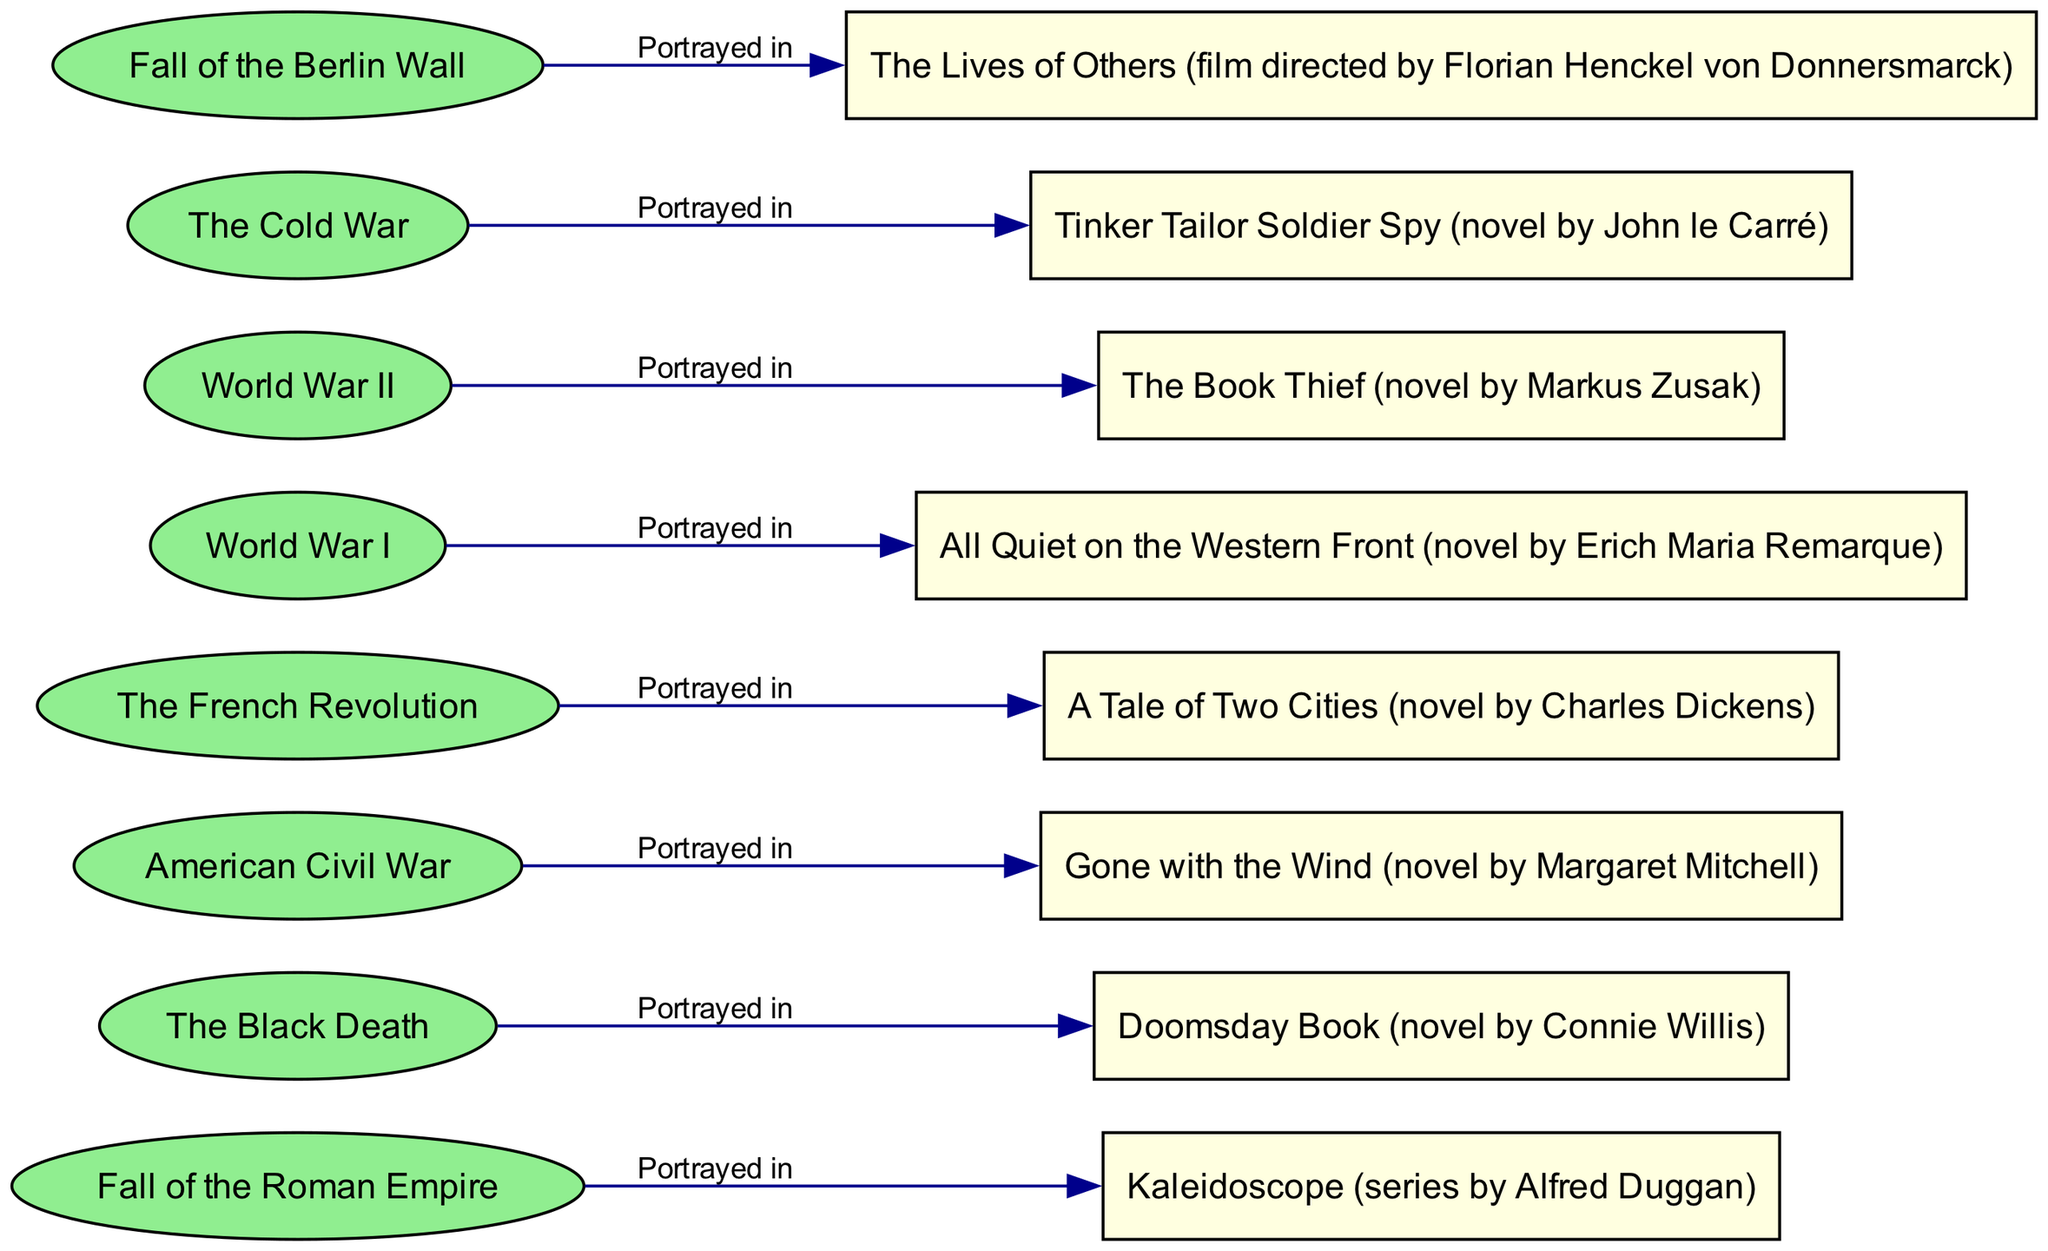What event is portrayed in "Gone with the Wind"? To answer this question, one must locate the fictional portrayal "Gone with the Wind" in the diagram and trace the connecting edge back to the event node. This indicates the event associated with that portrayal. The diagram shows that "Gone with the Wind" is linked to the "American Civil War".
Answer: American Civil War How many fictional portrayals are associated with the Fall of the Roman Empire? This question requires counting the number of nodes connected to the "Fall of the Roman Empire" event node. By examining the diagram, it can be seen that there is only one portrayal linking to this event, which is "Kaleidoscope".
Answer: 1 What are the two events depicted in the diagram that occurred during a global conflict? To answer this, one should identify which events in the diagram are related to global conflicts. "World War I" and "World War II" are both events that clearly match this criteria, as they influence vast geographic areas and numerous nations. The diagram presents both these events as separate nodes.
Answer: World War I, World War II Which fictional portrayal corresponds to the event "The Black Death"? The answer lies in locating the node labeled "The Black Death" and identifying the edge that links it to its corresponding fictional portrayal. The diagram clearly indicates that "The Black Death" is portrayed in "Doomsday Book".
Answer: Doomsday Book Which historical event has the fictional portrayal "Tinker Tailor Soldier Spy"? To answer this, find the node "Tinker Tailor Soldier Spy" in the diagram and trace its connecting edge back to see the event it represents. Following this path reveals that this fictional portrayal corresponds to the event "The Cold War".
Answer: The Cold War How many edges are present in the diagram? To find the number of edges, one must count the connections between the event and portrayal nodes. Each event is connected to its respective portrayal with a single edge. Since there are eight events, there are eight edges indicated in the diagram.
Answer: 8 Which fictional portrayal is associated with the event "Fall of the Berlin Wall"? To find the answer, locate the node labeled "Fall of the Berlin Wall" in the diagram and observe the linked portrayal. The edge indicates that it is associated with "The Lives of Others".
Answer: The Lives of Others What is the relationship between "World War I" and its fictional portrayal? This question requires analyzing the edge connecting "World War I" to its portrayal. The diagram shows a direct connection indicating that "World War I" is portrayed in "All Quiet on the Western Front".
Answer: Portrayed in All Quiet on the Western Front 